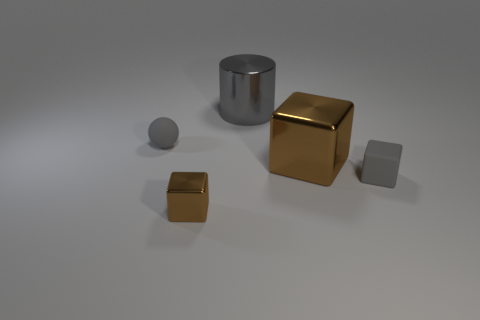Are there fewer blue metallic cylinders than metallic cubes?
Your answer should be very brief. Yes. There is a gray thing that is behind the rubber object that is behind the brown shiny cube that is behind the tiny brown metallic object; what is it made of?
Ensure brevity in your answer.  Metal. Does the brown thing in front of the matte cube have the same material as the large object behind the tiny rubber ball?
Offer a terse response. Yes. There is a gray thing that is both in front of the cylinder and behind the big cube; how big is it?
Make the answer very short. Small. There is a gray block that is the same size as the gray ball; what is its material?
Your answer should be very brief. Rubber. How many small objects are to the right of the thing that is behind the small gray rubber object on the left side of the tiny brown object?
Keep it short and to the point. 1. Does the tiny matte cube that is to the right of the gray matte ball have the same color as the metallic thing in front of the rubber block?
Give a very brief answer. No. There is a object that is behind the big brown shiny thing and left of the gray metallic thing; what is its color?
Your response must be concise. Gray. How many shiny cubes have the same size as the gray cylinder?
Give a very brief answer. 1. There is a metallic object that is in front of the tiny gray matte object that is to the right of the gray ball; what shape is it?
Your response must be concise. Cube. 